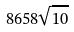<formula> <loc_0><loc_0><loc_500><loc_500>8 6 5 8 \sqrt { 1 0 }</formula> 